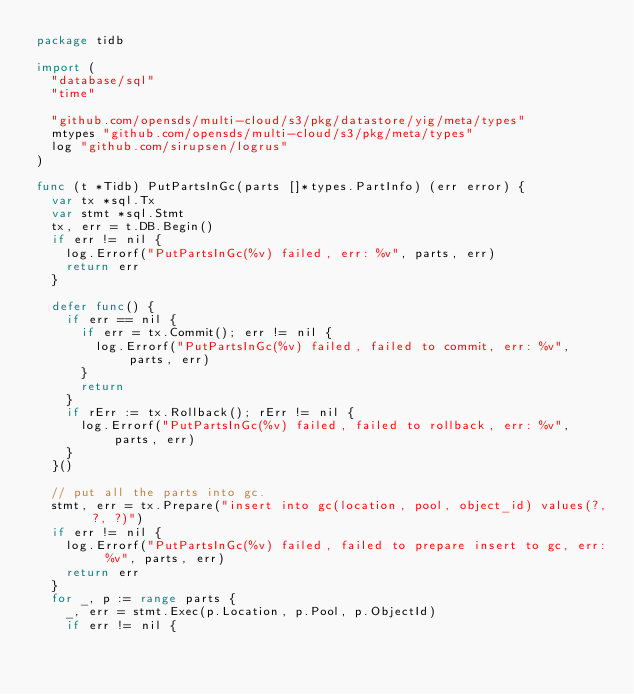<code> <loc_0><loc_0><loc_500><loc_500><_Go_>package tidb

import (
	"database/sql"
	"time"

	"github.com/opensds/multi-cloud/s3/pkg/datastore/yig/meta/types"
	mtypes "github.com/opensds/multi-cloud/s3/pkg/meta/types"
	log "github.com/sirupsen/logrus"
)

func (t *Tidb) PutPartsInGc(parts []*types.PartInfo) (err error) {
	var tx *sql.Tx
	var stmt *sql.Stmt
	tx, err = t.DB.Begin()
	if err != nil {
		log.Errorf("PutPartsInGc(%v) failed, err: %v", parts, err)
		return err
	}

	defer func() {
		if err == nil {
			if err = tx.Commit(); err != nil {
				log.Errorf("PutPartsInGc(%v) failed, failed to commit, err: %v", parts, err)
			}
			return
		}
		if rErr := tx.Rollback(); rErr != nil {
			log.Errorf("PutPartsInGc(%v) failed, failed to rollback, err: %v", parts, err)
		}
	}()

	// put all the parts into gc.
	stmt, err = tx.Prepare("insert into gc(location, pool, object_id) values(?, ?, ?)")
	if err != nil {
		log.Errorf("PutPartsInGc(%v) failed, failed to prepare insert to gc, err: %v", parts, err)
		return err
	}
	for _, p := range parts {
		_, err = stmt.Exec(p.Location, p.Pool, p.ObjectId)
		if err != nil {</code> 